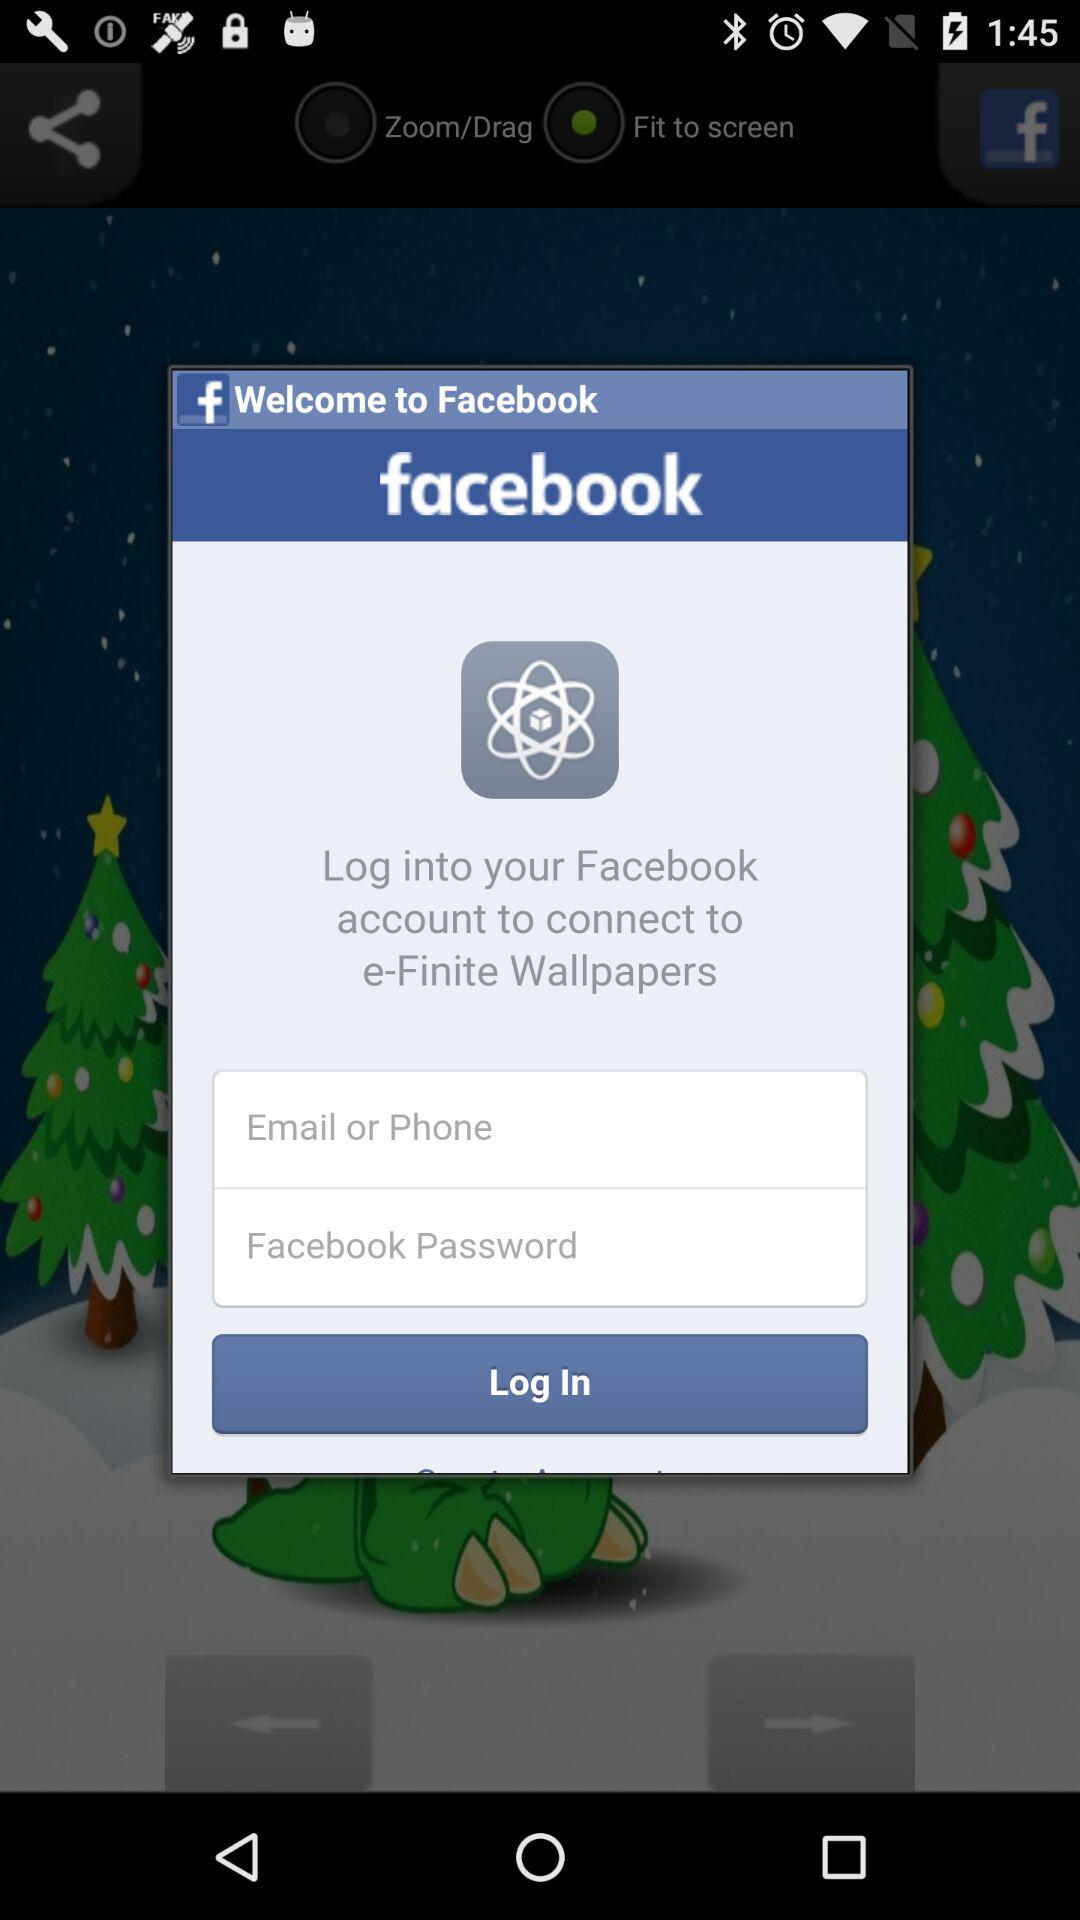What is the application name? The application name is "Facebook". 